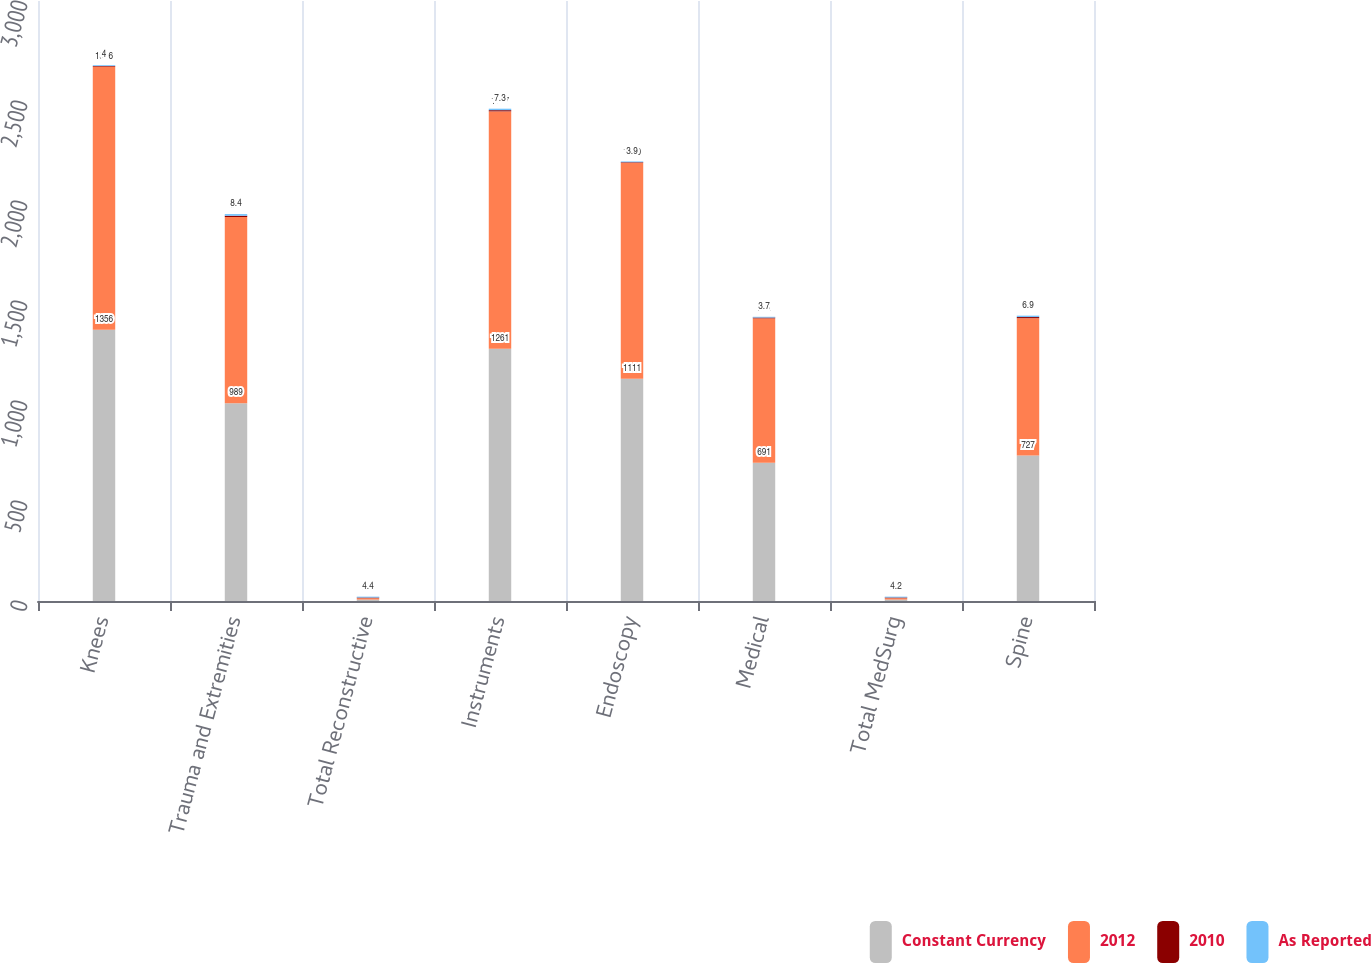Convert chart to OTSL. <chart><loc_0><loc_0><loc_500><loc_500><stacked_bar_chart><ecel><fcel>Knees<fcel>Trauma and Extremities<fcel>Total Reconstructive<fcel>Instruments<fcel>Endoscopy<fcel>Medical<fcel>Total MedSurg<fcel>Spine<nl><fcel>Constant Currency<fcel>1356<fcel>989<fcel>7.1<fcel>1261<fcel>1111<fcel>691<fcel>7.1<fcel>727<nl><fcel>2012<fcel>1316<fcel>931<fcel>7.1<fcel>1187<fcel>1080<fcel>722<fcel>7.1<fcel>687<nl><fcel>2010<fcel>3<fcel>6.2<fcel>3.1<fcel>6.2<fcel>2.9<fcel>4.3<fcel>3.3<fcel>5.8<nl><fcel>As Reported<fcel>4<fcel>8.4<fcel>4.4<fcel>7.3<fcel>3.9<fcel>3.7<fcel>4.2<fcel>6.9<nl></chart> 